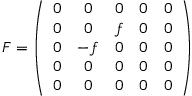<formula> <loc_0><loc_0><loc_500><loc_500>F = \left ( \begin{array} { c c c c c } { 0 } & { 0 } & { 0 } & { 0 } & { 0 } \\ { 0 } & { 0 } & { f } & { 0 } & { 0 } \\ { 0 } & { - f } & { 0 } & { 0 } & { 0 } \\ { 0 } & { 0 } & { 0 } & { 0 } & { 0 } \\ { 0 } & { 0 } & { 0 } & { 0 } & { 0 } \end{array} \right )</formula> 